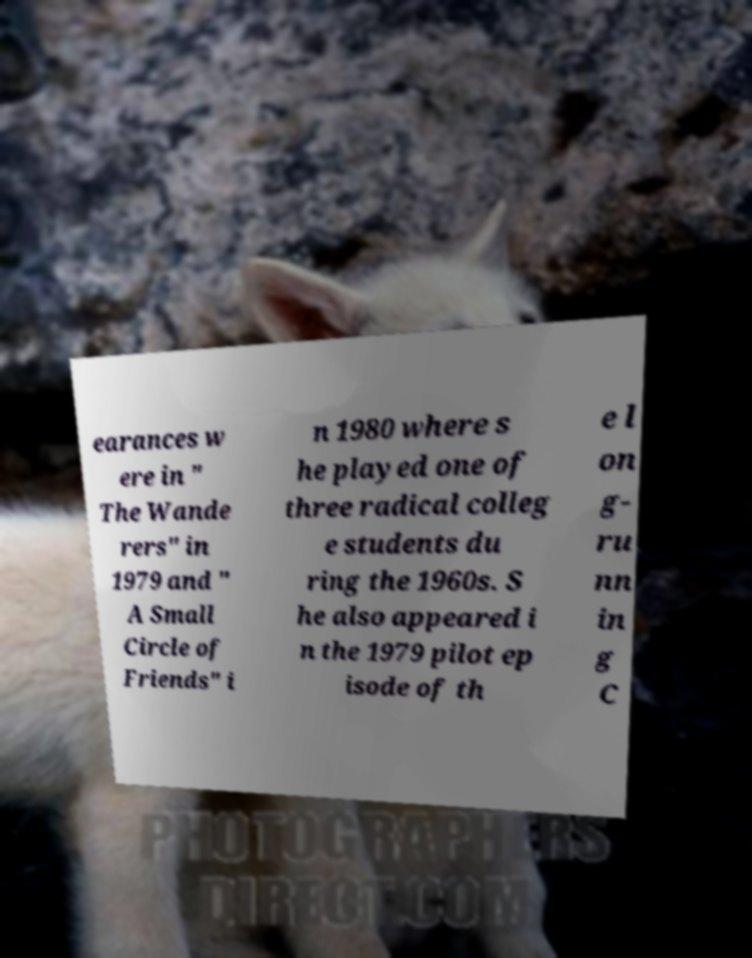I need the written content from this picture converted into text. Can you do that? earances w ere in " The Wande rers" in 1979 and " A Small Circle of Friends" i n 1980 where s he played one of three radical colleg e students du ring the 1960s. S he also appeared i n the 1979 pilot ep isode of th e l on g- ru nn in g C 